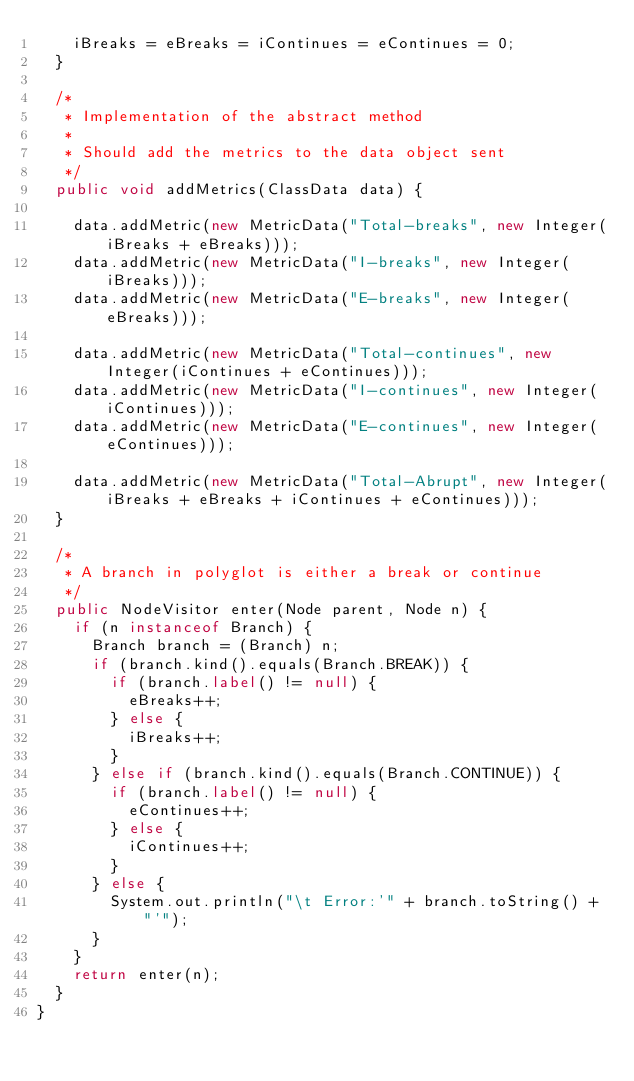Convert code to text. <code><loc_0><loc_0><loc_500><loc_500><_Java_>    iBreaks = eBreaks = iContinues = eContinues = 0;
  }

  /*
   * Implementation of the abstract method
   *
   * Should add the metrics to the data object sent
   */
  public void addMetrics(ClassData data) {

    data.addMetric(new MetricData("Total-breaks", new Integer(iBreaks + eBreaks)));
    data.addMetric(new MetricData("I-breaks", new Integer(iBreaks)));
    data.addMetric(new MetricData("E-breaks", new Integer(eBreaks)));

    data.addMetric(new MetricData("Total-continues", new Integer(iContinues + eContinues)));
    data.addMetric(new MetricData("I-continues", new Integer(iContinues)));
    data.addMetric(new MetricData("E-continues", new Integer(eContinues)));

    data.addMetric(new MetricData("Total-Abrupt", new Integer(iBreaks + eBreaks + iContinues + eContinues)));
  }

  /*
   * A branch in polyglot is either a break or continue
   */
  public NodeVisitor enter(Node parent, Node n) {
    if (n instanceof Branch) {
      Branch branch = (Branch) n;
      if (branch.kind().equals(Branch.BREAK)) {
        if (branch.label() != null) {
          eBreaks++;
        } else {
          iBreaks++;
        }
      } else if (branch.kind().equals(Branch.CONTINUE)) {
        if (branch.label() != null) {
          eContinues++;
        } else {
          iContinues++;
        }
      } else {
        System.out.println("\t Error:'" + branch.toString() + "'");
      }
    }
    return enter(n);
  }
}
</code> 